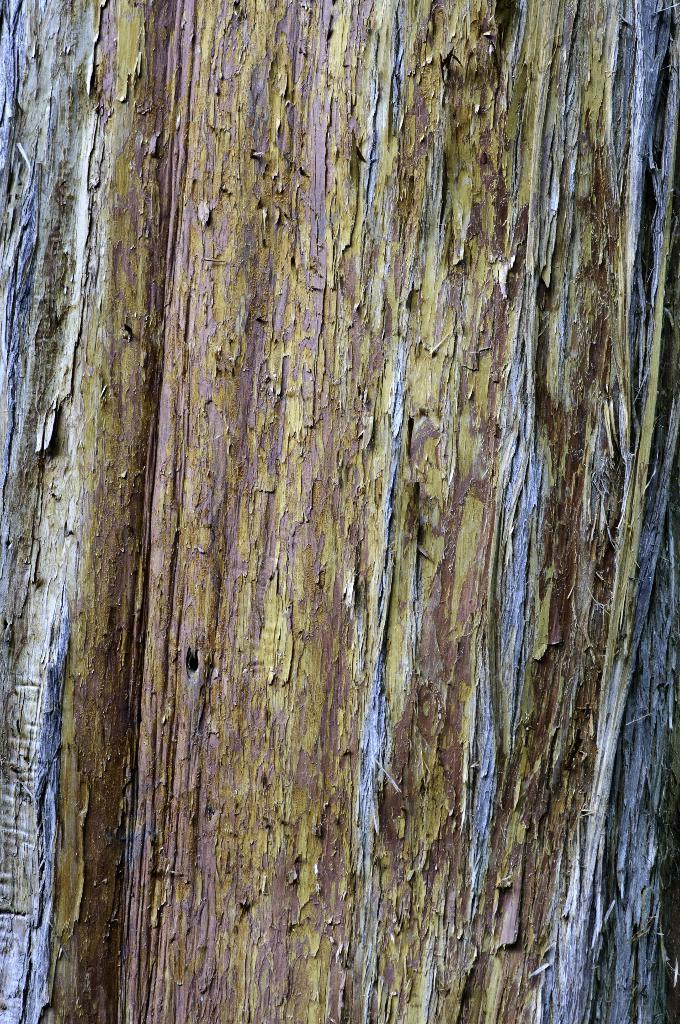In one or two sentences, can you explain what this image depicts? In the image in the center, we can see the wood. 